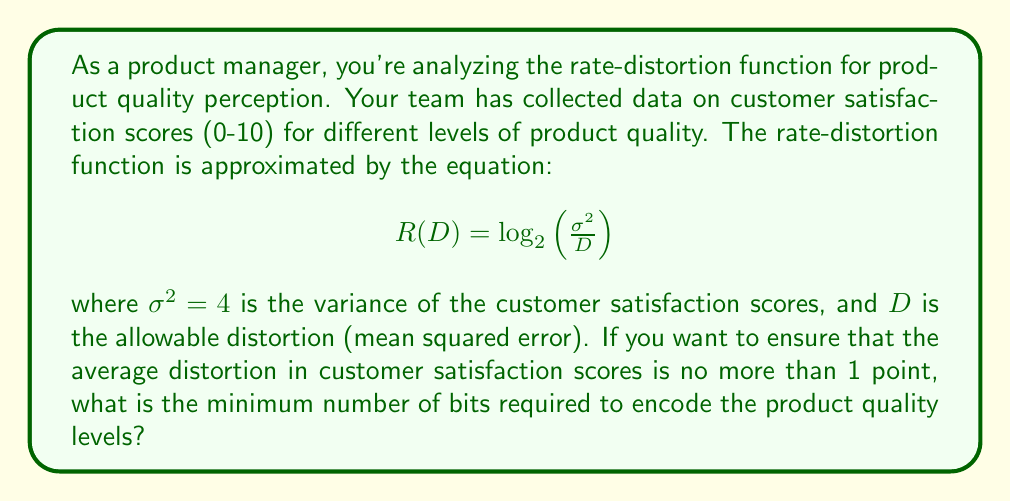Can you solve this math problem? To solve this problem, we need to follow these steps:

1. Identify the given information:
   - Rate-distortion function: $R(D) = \log_2\left(\frac{\sigma^2}{D}\right)$
   - Variance of customer satisfaction scores: $\sigma^2 = 4$
   - Allowable distortion: $D = 1$ (since we want the average distortion to be no more than 1 point)

2. Substitute the values into the rate-distortion function:
   $$R(1) = \log_2\left(\frac{4}{1}\right)$$

3. Simplify the equation:
   $$R(1) = \log_2(4)$$

4. Calculate the result:
   $$R(1) = 2$$

5. Interpret the result:
   The rate-distortion function gives us the minimum number of bits required to encode the product quality levels while maintaining the specified distortion level. In this case, we need 2 bits to encode the quality levels.

6. Round up to the nearest integer:
   Since we can't use fractional bits in practice, we need to round up to the nearest integer. In this case, 2 is already an integer, so no rounding is necessary.

Therefore, the minimum number of bits required to encode the product quality levels while ensuring an average distortion of no more than 1 point in customer satisfaction scores is 2 bits.
Answer: 2 bits 